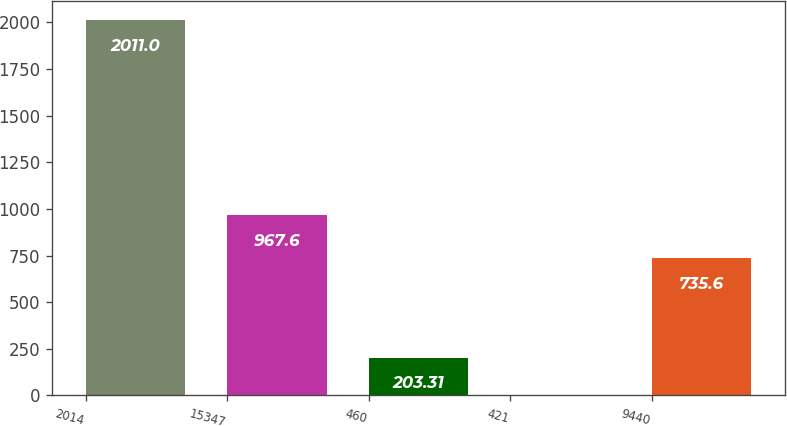Convert chart. <chart><loc_0><loc_0><loc_500><loc_500><bar_chart><fcel>2014<fcel>15347<fcel>460<fcel>421<fcel>9440<nl><fcel>2011<fcel>967.6<fcel>203.31<fcel>2.46<fcel>735.6<nl></chart> 